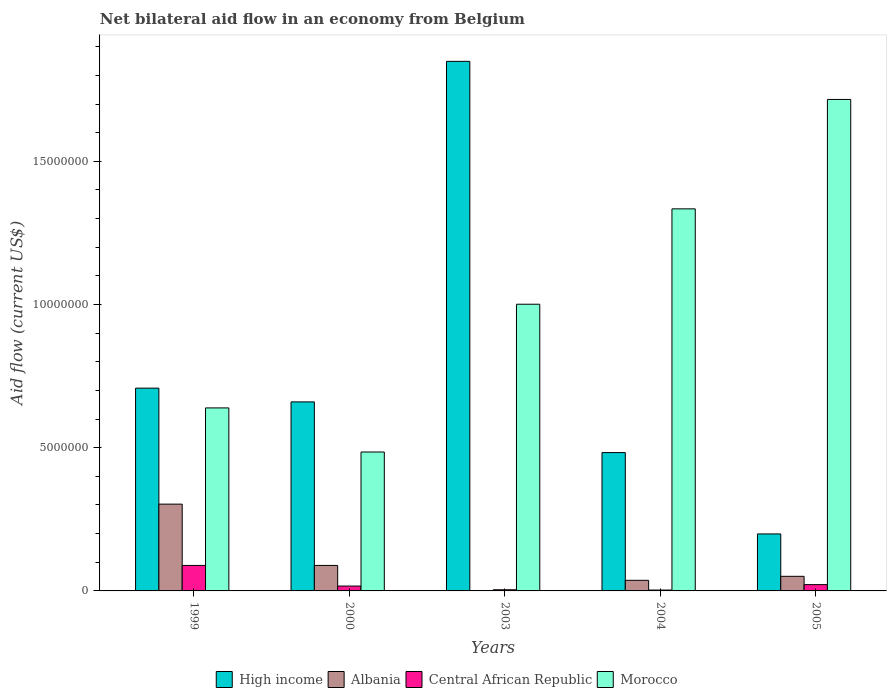How many different coloured bars are there?
Your answer should be very brief. 4. Are the number of bars per tick equal to the number of legend labels?
Keep it short and to the point. Yes. Are the number of bars on each tick of the X-axis equal?
Make the answer very short. Yes. How many bars are there on the 1st tick from the left?
Provide a succinct answer. 4. What is the label of the 3rd group of bars from the left?
Ensure brevity in your answer.  2003. In how many cases, is the number of bars for a given year not equal to the number of legend labels?
Your response must be concise. 0. What is the net bilateral aid flow in Albania in 2005?
Give a very brief answer. 5.10e+05. Across all years, what is the maximum net bilateral aid flow in Central African Republic?
Keep it short and to the point. 8.90e+05. Across all years, what is the minimum net bilateral aid flow in Morocco?
Provide a short and direct response. 4.85e+06. In which year was the net bilateral aid flow in Albania minimum?
Your response must be concise. 2003. What is the total net bilateral aid flow in Albania in the graph?
Provide a short and direct response. 4.81e+06. What is the difference between the net bilateral aid flow in Albania in 2003 and that in 2005?
Provide a short and direct response. -5.00e+05. What is the difference between the net bilateral aid flow in Morocco in 2000 and the net bilateral aid flow in High income in 2003?
Make the answer very short. -1.36e+07. What is the average net bilateral aid flow in Albania per year?
Keep it short and to the point. 9.62e+05. What is the ratio of the net bilateral aid flow in High income in 2000 to that in 2003?
Offer a terse response. 0.36. Is the difference between the net bilateral aid flow in Central African Republic in 2004 and 2005 greater than the difference between the net bilateral aid flow in Albania in 2004 and 2005?
Make the answer very short. No. What is the difference between the highest and the second highest net bilateral aid flow in Central African Republic?
Ensure brevity in your answer.  6.70e+05. What is the difference between the highest and the lowest net bilateral aid flow in Central African Republic?
Keep it short and to the point. 8.60e+05. What does the 1st bar from the left in 1999 represents?
Offer a terse response. High income. Are all the bars in the graph horizontal?
Provide a succinct answer. No. How many years are there in the graph?
Offer a very short reply. 5. What is the difference between two consecutive major ticks on the Y-axis?
Keep it short and to the point. 5.00e+06. Does the graph contain grids?
Your answer should be compact. No. Where does the legend appear in the graph?
Offer a very short reply. Bottom center. What is the title of the graph?
Give a very brief answer. Net bilateral aid flow in an economy from Belgium. What is the label or title of the Y-axis?
Give a very brief answer. Aid flow (current US$). What is the Aid flow (current US$) in High income in 1999?
Ensure brevity in your answer.  7.08e+06. What is the Aid flow (current US$) in Albania in 1999?
Your response must be concise. 3.03e+06. What is the Aid flow (current US$) of Central African Republic in 1999?
Provide a succinct answer. 8.90e+05. What is the Aid flow (current US$) of Morocco in 1999?
Offer a very short reply. 6.39e+06. What is the Aid flow (current US$) in High income in 2000?
Ensure brevity in your answer.  6.60e+06. What is the Aid flow (current US$) of Albania in 2000?
Your answer should be compact. 8.90e+05. What is the Aid flow (current US$) of Central African Republic in 2000?
Offer a very short reply. 1.70e+05. What is the Aid flow (current US$) of Morocco in 2000?
Offer a terse response. 4.85e+06. What is the Aid flow (current US$) of High income in 2003?
Provide a succinct answer. 1.85e+07. What is the Aid flow (current US$) of Central African Republic in 2003?
Make the answer very short. 4.00e+04. What is the Aid flow (current US$) of Morocco in 2003?
Your answer should be very brief. 1.00e+07. What is the Aid flow (current US$) of High income in 2004?
Provide a succinct answer. 4.83e+06. What is the Aid flow (current US$) in Albania in 2004?
Keep it short and to the point. 3.70e+05. What is the Aid flow (current US$) of Morocco in 2004?
Keep it short and to the point. 1.33e+07. What is the Aid flow (current US$) of High income in 2005?
Ensure brevity in your answer.  1.99e+06. What is the Aid flow (current US$) of Albania in 2005?
Your response must be concise. 5.10e+05. What is the Aid flow (current US$) in Morocco in 2005?
Provide a short and direct response. 1.72e+07. Across all years, what is the maximum Aid flow (current US$) of High income?
Give a very brief answer. 1.85e+07. Across all years, what is the maximum Aid flow (current US$) in Albania?
Provide a short and direct response. 3.03e+06. Across all years, what is the maximum Aid flow (current US$) of Central African Republic?
Offer a very short reply. 8.90e+05. Across all years, what is the maximum Aid flow (current US$) of Morocco?
Offer a terse response. 1.72e+07. Across all years, what is the minimum Aid flow (current US$) of High income?
Ensure brevity in your answer.  1.99e+06. Across all years, what is the minimum Aid flow (current US$) in Morocco?
Ensure brevity in your answer.  4.85e+06. What is the total Aid flow (current US$) in High income in the graph?
Give a very brief answer. 3.90e+07. What is the total Aid flow (current US$) in Albania in the graph?
Keep it short and to the point. 4.81e+06. What is the total Aid flow (current US$) in Central African Republic in the graph?
Provide a short and direct response. 1.35e+06. What is the total Aid flow (current US$) of Morocco in the graph?
Offer a terse response. 5.18e+07. What is the difference between the Aid flow (current US$) in High income in 1999 and that in 2000?
Your answer should be compact. 4.80e+05. What is the difference between the Aid flow (current US$) in Albania in 1999 and that in 2000?
Make the answer very short. 2.14e+06. What is the difference between the Aid flow (current US$) of Central African Republic in 1999 and that in 2000?
Make the answer very short. 7.20e+05. What is the difference between the Aid flow (current US$) of Morocco in 1999 and that in 2000?
Ensure brevity in your answer.  1.54e+06. What is the difference between the Aid flow (current US$) in High income in 1999 and that in 2003?
Your answer should be compact. -1.14e+07. What is the difference between the Aid flow (current US$) in Albania in 1999 and that in 2003?
Provide a short and direct response. 3.02e+06. What is the difference between the Aid flow (current US$) in Central African Republic in 1999 and that in 2003?
Your answer should be compact. 8.50e+05. What is the difference between the Aid flow (current US$) in Morocco in 1999 and that in 2003?
Provide a succinct answer. -3.62e+06. What is the difference between the Aid flow (current US$) of High income in 1999 and that in 2004?
Offer a very short reply. 2.25e+06. What is the difference between the Aid flow (current US$) in Albania in 1999 and that in 2004?
Keep it short and to the point. 2.66e+06. What is the difference between the Aid flow (current US$) of Central African Republic in 1999 and that in 2004?
Your answer should be very brief. 8.60e+05. What is the difference between the Aid flow (current US$) in Morocco in 1999 and that in 2004?
Offer a terse response. -6.95e+06. What is the difference between the Aid flow (current US$) in High income in 1999 and that in 2005?
Your response must be concise. 5.09e+06. What is the difference between the Aid flow (current US$) of Albania in 1999 and that in 2005?
Provide a succinct answer. 2.52e+06. What is the difference between the Aid flow (current US$) in Central African Republic in 1999 and that in 2005?
Your answer should be very brief. 6.70e+05. What is the difference between the Aid flow (current US$) of Morocco in 1999 and that in 2005?
Your answer should be very brief. -1.08e+07. What is the difference between the Aid flow (current US$) in High income in 2000 and that in 2003?
Provide a short and direct response. -1.19e+07. What is the difference between the Aid flow (current US$) of Albania in 2000 and that in 2003?
Provide a short and direct response. 8.80e+05. What is the difference between the Aid flow (current US$) in Central African Republic in 2000 and that in 2003?
Give a very brief answer. 1.30e+05. What is the difference between the Aid flow (current US$) of Morocco in 2000 and that in 2003?
Give a very brief answer. -5.16e+06. What is the difference between the Aid flow (current US$) of High income in 2000 and that in 2004?
Provide a short and direct response. 1.77e+06. What is the difference between the Aid flow (current US$) in Albania in 2000 and that in 2004?
Provide a short and direct response. 5.20e+05. What is the difference between the Aid flow (current US$) of Central African Republic in 2000 and that in 2004?
Your answer should be compact. 1.40e+05. What is the difference between the Aid flow (current US$) of Morocco in 2000 and that in 2004?
Offer a very short reply. -8.49e+06. What is the difference between the Aid flow (current US$) in High income in 2000 and that in 2005?
Your answer should be very brief. 4.61e+06. What is the difference between the Aid flow (current US$) of Albania in 2000 and that in 2005?
Your answer should be compact. 3.80e+05. What is the difference between the Aid flow (current US$) in Morocco in 2000 and that in 2005?
Your response must be concise. -1.23e+07. What is the difference between the Aid flow (current US$) in High income in 2003 and that in 2004?
Provide a short and direct response. 1.37e+07. What is the difference between the Aid flow (current US$) in Albania in 2003 and that in 2004?
Ensure brevity in your answer.  -3.60e+05. What is the difference between the Aid flow (current US$) in Central African Republic in 2003 and that in 2004?
Provide a succinct answer. 10000. What is the difference between the Aid flow (current US$) in Morocco in 2003 and that in 2004?
Provide a short and direct response. -3.33e+06. What is the difference between the Aid flow (current US$) in High income in 2003 and that in 2005?
Your answer should be very brief. 1.65e+07. What is the difference between the Aid flow (current US$) of Albania in 2003 and that in 2005?
Your answer should be compact. -5.00e+05. What is the difference between the Aid flow (current US$) in Central African Republic in 2003 and that in 2005?
Your response must be concise. -1.80e+05. What is the difference between the Aid flow (current US$) of Morocco in 2003 and that in 2005?
Keep it short and to the point. -7.15e+06. What is the difference between the Aid flow (current US$) in High income in 2004 and that in 2005?
Give a very brief answer. 2.84e+06. What is the difference between the Aid flow (current US$) of Albania in 2004 and that in 2005?
Give a very brief answer. -1.40e+05. What is the difference between the Aid flow (current US$) of Morocco in 2004 and that in 2005?
Keep it short and to the point. -3.82e+06. What is the difference between the Aid flow (current US$) in High income in 1999 and the Aid flow (current US$) in Albania in 2000?
Your response must be concise. 6.19e+06. What is the difference between the Aid flow (current US$) in High income in 1999 and the Aid flow (current US$) in Central African Republic in 2000?
Offer a very short reply. 6.91e+06. What is the difference between the Aid flow (current US$) of High income in 1999 and the Aid flow (current US$) of Morocco in 2000?
Your answer should be very brief. 2.23e+06. What is the difference between the Aid flow (current US$) of Albania in 1999 and the Aid flow (current US$) of Central African Republic in 2000?
Make the answer very short. 2.86e+06. What is the difference between the Aid flow (current US$) in Albania in 1999 and the Aid flow (current US$) in Morocco in 2000?
Your answer should be compact. -1.82e+06. What is the difference between the Aid flow (current US$) of Central African Republic in 1999 and the Aid flow (current US$) of Morocco in 2000?
Ensure brevity in your answer.  -3.96e+06. What is the difference between the Aid flow (current US$) in High income in 1999 and the Aid flow (current US$) in Albania in 2003?
Keep it short and to the point. 7.07e+06. What is the difference between the Aid flow (current US$) of High income in 1999 and the Aid flow (current US$) of Central African Republic in 2003?
Offer a very short reply. 7.04e+06. What is the difference between the Aid flow (current US$) in High income in 1999 and the Aid flow (current US$) in Morocco in 2003?
Your response must be concise. -2.93e+06. What is the difference between the Aid flow (current US$) of Albania in 1999 and the Aid flow (current US$) of Central African Republic in 2003?
Your answer should be compact. 2.99e+06. What is the difference between the Aid flow (current US$) of Albania in 1999 and the Aid flow (current US$) of Morocco in 2003?
Provide a succinct answer. -6.98e+06. What is the difference between the Aid flow (current US$) of Central African Republic in 1999 and the Aid flow (current US$) of Morocco in 2003?
Your response must be concise. -9.12e+06. What is the difference between the Aid flow (current US$) of High income in 1999 and the Aid flow (current US$) of Albania in 2004?
Ensure brevity in your answer.  6.71e+06. What is the difference between the Aid flow (current US$) of High income in 1999 and the Aid flow (current US$) of Central African Republic in 2004?
Provide a succinct answer. 7.05e+06. What is the difference between the Aid flow (current US$) in High income in 1999 and the Aid flow (current US$) in Morocco in 2004?
Your response must be concise. -6.26e+06. What is the difference between the Aid flow (current US$) of Albania in 1999 and the Aid flow (current US$) of Morocco in 2004?
Keep it short and to the point. -1.03e+07. What is the difference between the Aid flow (current US$) in Central African Republic in 1999 and the Aid flow (current US$) in Morocco in 2004?
Ensure brevity in your answer.  -1.24e+07. What is the difference between the Aid flow (current US$) of High income in 1999 and the Aid flow (current US$) of Albania in 2005?
Provide a short and direct response. 6.57e+06. What is the difference between the Aid flow (current US$) of High income in 1999 and the Aid flow (current US$) of Central African Republic in 2005?
Keep it short and to the point. 6.86e+06. What is the difference between the Aid flow (current US$) in High income in 1999 and the Aid flow (current US$) in Morocco in 2005?
Your response must be concise. -1.01e+07. What is the difference between the Aid flow (current US$) in Albania in 1999 and the Aid flow (current US$) in Central African Republic in 2005?
Ensure brevity in your answer.  2.81e+06. What is the difference between the Aid flow (current US$) in Albania in 1999 and the Aid flow (current US$) in Morocco in 2005?
Your response must be concise. -1.41e+07. What is the difference between the Aid flow (current US$) in Central African Republic in 1999 and the Aid flow (current US$) in Morocco in 2005?
Keep it short and to the point. -1.63e+07. What is the difference between the Aid flow (current US$) in High income in 2000 and the Aid flow (current US$) in Albania in 2003?
Your response must be concise. 6.59e+06. What is the difference between the Aid flow (current US$) of High income in 2000 and the Aid flow (current US$) of Central African Republic in 2003?
Offer a terse response. 6.56e+06. What is the difference between the Aid flow (current US$) in High income in 2000 and the Aid flow (current US$) in Morocco in 2003?
Provide a succinct answer. -3.41e+06. What is the difference between the Aid flow (current US$) in Albania in 2000 and the Aid flow (current US$) in Central African Republic in 2003?
Your answer should be very brief. 8.50e+05. What is the difference between the Aid flow (current US$) of Albania in 2000 and the Aid flow (current US$) of Morocco in 2003?
Ensure brevity in your answer.  -9.12e+06. What is the difference between the Aid flow (current US$) of Central African Republic in 2000 and the Aid flow (current US$) of Morocco in 2003?
Offer a terse response. -9.84e+06. What is the difference between the Aid flow (current US$) of High income in 2000 and the Aid flow (current US$) of Albania in 2004?
Offer a very short reply. 6.23e+06. What is the difference between the Aid flow (current US$) in High income in 2000 and the Aid flow (current US$) in Central African Republic in 2004?
Offer a terse response. 6.57e+06. What is the difference between the Aid flow (current US$) in High income in 2000 and the Aid flow (current US$) in Morocco in 2004?
Your response must be concise. -6.74e+06. What is the difference between the Aid flow (current US$) in Albania in 2000 and the Aid flow (current US$) in Central African Republic in 2004?
Give a very brief answer. 8.60e+05. What is the difference between the Aid flow (current US$) of Albania in 2000 and the Aid flow (current US$) of Morocco in 2004?
Offer a terse response. -1.24e+07. What is the difference between the Aid flow (current US$) in Central African Republic in 2000 and the Aid flow (current US$) in Morocco in 2004?
Offer a very short reply. -1.32e+07. What is the difference between the Aid flow (current US$) of High income in 2000 and the Aid flow (current US$) of Albania in 2005?
Provide a short and direct response. 6.09e+06. What is the difference between the Aid flow (current US$) of High income in 2000 and the Aid flow (current US$) of Central African Republic in 2005?
Keep it short and to the point. 6.38e+06. What is the difference between the Aid flow (current US$) of High income in 2000 and the Aid flow (current US$) of Morocco in 2005?
Your response must be concise. -1.06e+07. What is the difference between the Aid flow (current US$) of Albania in 2000 and the Aid flow (current US$) of Central African Republic in 2005?
Ensure brevity in your answer.  6.70e+05. What is the difference between the Aid flow (current US$) in Albania in 2000 and the Aid flow (current US$) in Morocco in 2005?
Your answer should be compact. -1.63e+07. What is the difference between the Aid flow (current US$) of Central African Republic in 2000 and the Aid flow (current US$) of Morocco in 2005?
Offer a very short reply. -1.70e+07. What is the difference between the Aid flow (current US$) in High income in 2003 and the Aid flow (current US$) in Albania in 2004?
Provide a succinct answer. 1.81e+07. What is the difference between the Aid flow (current US$) in High income in 2003 and the Aid flow (current US$) in Central African Republic in 2004?
Ensure brevity in your answer.  1.85e+07. What is the difference between the Aid flow (current US$) in High income in 2003 and the Aid flow (current US$) in Morocco in 2004?
Offer a terse response. 5.15e+06. What is the difference between the Aid flow (current US$) in Albania in 2003 and the Aid flow (current US$) in Morocco in 2004?
Provide a short and direct response. -1.33e+07. What is the difference between the Aid flow (current US$) in Central African Republic in 2003 and the Aid flow (current US$) in Morocco in 2004?
Keep it short and to the point. -1.33e+07. What is the difference between the Aid flow (current US$) in High income in 2003 and the Aid flow (current US$) in Albania in 2005?
Ensure brevity in your answer.  1.80e+07. What is the difference between the Aid flow (current US$) of High income in 2003 and the Aid flow (current US$) of Central African Republic in 2005?
Offer a very short reply. 1.83e+07. What is the difference between the Aid flow (current US$) of High income in 2003 and the Aid flow (current US$) of Morocco in 2005?
Your answer should be compact. 1.33e+06. What is the difference between the Aid flow (current US$) of Albania in 2003 and the Aid flow (current US$) of Central African Republic in 2005?
Offer a very short reply. -2.10e+05. What is the difference between the Aid flow (current US$) in Albania in 2003 and the Aid flow (current US$) in Morocco in 2005?
Make the answer very short. -1.72e+07. What is the difference between the Aid flow (current US$) in Central African Republic in 2003 and the Aid flow (current US$) in Morocco in 2005?
Give a very brief answer. -1.71e+07. What is the difference between the Aid flow (current US$) of High income in 2004 and the Aid flow (current US$) of Albania in 2005?
Provide a short and direct response. 4.32e+06. What is the difference between the Aid flow (current US$) in High income in 2004 and the Aid flow (current US$) in Central African Republic in 2005?
Your answer should be compact. 4.61e+06. What is the difference between the Aid flow (current US$) in High income in 2004 and the Aid flow (current US$) in Morocco in 2005?
Give a very brief answer. -1.23e+07. What is the difference between the Aid flow (current US$) of Albania in 2004 and the Aid flow (current US$) of Central African Republic in 2005?
Offer a very short reply. 1.50e+05. What is the difference between the Aid flow (current US$) in Albania in 2004 and the Aid flow (current US$) in Morocco in 2005?
Offer a terse response. -1.68e+07. What is the difference between the Aid flow (current US$) of Central African Republic in 2004 and the Aid flow (current US$) of Morocco in 2005?
Your answer should be compact. -1.71e+07. What is the average Aid flow (current US$) in High income per year?
Make the answer very short. 7.80e+06. What is the average Aid flow (current US$) in Albania per year?
Keep it short and to the point. 9.62e+05. What is the average Aid flow (current US$) of Morocco per year?
Ensure brevity in your answer.  1.04e+07. In the year 1999, what is the difference between the Aid flow (current US$) in High income and Aid flow (current US$) in Albania?
Make the answer very short. 4.05e+06. In the year 1999, what is the difference between the Aid flow (current US$) of High income and Aid flow (current US$) of Central African Republic?
Make the answer very short. 6.19e+06. In the year 1999, what is the difference between the Aid flow (current US$) in High income and Aid flow (current US$) in Morocco?
Offer a very short reply. 6.90e+05. In the year 1999, what is the difference between the Aid flow (current US$) of Albania and Aid flow (current US$) of Central African Republic?
Ensure brevity in your answer.  2.14e+06. In the year 1999, what is the difference between the Aid flow (current US$) in Albania and Aid flow (current US$) in Morocco?
Your answer should be very brief. -3.36e+06. In the year 1999, what is the difference between the Aid flow (current US$) of Central African Republic and Aid flow (current US$) of Morocco?
Give a very brief answer. -5.50e+06. In the year 2000, what is the difference between the Aid flow (current US$) in High income and Aid flow (current US$) in Albania?
Provide a short and direct response. 5.71e+06. In the year 2000, what is the difference between the Aid flow (current US$) of High income and Aid flow (current US$) of Central African Republic?
Offer a very short reply. 6.43e+06. In the year 2000, what is the difference between the Aid flow (current US$) of High income and Aid flow (current US$) of Morocco?
Your answer should be compact. 1.75e+06. In the year 2000, what is the difference between the Aid flow (current US$) of Albania and Aid flow (current US$) of Central African Republic?
Your answer should be compact. 7.20e+05. In the year 2000, what is the difference between the Aid flow (current US$) in Albania and Aid flow (current US$) in Morocco?
Ensure brevity in your answer.  -3.96e+06. In the year 2000, what is the difference between the Aid flow (current US$) of Central African Republic and Aid flow (current US$) of Morocco?
Your response must be concise. -4.68e+06. In the year 2003, what is the difference between the Aid flow (current US$) in High income and Aid flow (current US$) in Albania?
Your answer should be compact. 1.85e+07. In the year 2003, what is the difference between the Aid flow (current US$) of High income and Aid flow (current US$) of Central African Republic?
Your answer should be very brief. 1.84e+07. In the year 2003, what is the difference between the Aid flow (current US$) in High income and Aid flow (current US$) in Morocco?
Provide a short and direct response. 8.48e+06. In the year 2003, what is the difference between the Aid flow (current US$) in Albania and Aid flow (current US$) in Morocco?
Your answer should be compact. -1.00e+07. In the year 2003, what is the difference between the Aid flow (current US$) of Central African Republic and Aid flow (current US$) of Morocco?
Offer a terse response. -9.97e+06. In the year 2004, what is the difference between the Aid flow (current US$) in High income and Aid flow (current US$) in Albania?
Offer a terse response. 4.46e+06. In the year 2004, what is the difference between the Aid flow (current US$) in High income and Aid flow (current US$) in Central African Republic?
Offer a terse response. 4.80e+06. In the year 2004, what is the difference between the Aid flow (current US$) of High income and Aid flow (current US$) of Morocco?
Your answer should be very brief. -8.51e+06. In the year 2004, what is the difference between the Aid flow (current US$) in Albania and Aid flow (current US$) in Central African Republic?
Keep it short and to the point. 3.40e+05. In the year 2004, what is the difference between the Aid flow (current US$) in Albania and Aid flow (current US$) in Morocco?
Offer a very short reply. -1.30e+07. In the year 2004, what is the difference between the Aid flow (current US$) in Central African Republic and Aid flow (current US$) in Morocco?
Give a very brief answer. -1.33e+07. In the year 2005, what is the difference between the Aid flow (current US$) of High income and Aid flow (current US$) of Albania?
Offer a terse response. 1.48e+06. In the year 2005, what is the difference between the Aid flow (current US$) of High income and Aid flow (current US$) of Central African Republic?
Offer a terse response. 1.77e+06. In the year 2005, what is the difference between the Aid flow (current US$) in High income and Aid flow (current US$) in Morocco?
Provide a succinct answer. -1.52e+07. In the year 2005, what is the difference between the Aid flow (current US$) in Albania and Aid flow (current US$) in Morocco?
Your response must be concise. -1.66e+07. In the year 2005, what is the difference between the Aid flow (current US$) of Central African Republic and Aid flow (current US$) of Morocco?
Your answer should be very brief. -1.69e+07. What is the ratio of the Aid flow (current US$) of High income in 1999 to that in 2000?
Keep it short and to the point. 1.07. What is the ratio of the Aid flow (current US$) of Albania in 1999 to that in 2000?
Keep it short and to the point. 3.4. What is the ratio of the Aid flow (current US$) of Central African Republic in 1999 to that in 2000?
Give a very brief answer. 5.24. What is the ratio of the Aid flow (current US$) of Morocco in 1999 to that in 2000?
Keep it short and to the point. 1.32. What is the ratio of the Aid flow (current US$) of High income in 1999 to that in 2003?
Your response must be concise. 0.38. What is the ratio of the Aid flow (current US$) in Albania in 1999 to that in 2003?
Keep it short and to the point. 303. What is the ratio of the Aid flow (current US$) in Central African Republic in 1999 to that in 2003?
Keep it short and to the point. 22.25. What is the ratio of the Aid flow (current US$) in Morocco in 1999 to that in 2003?
Ensure brevity in your answer.  0.64. What is the ratio of the Aid flow (current US$) in High income in 1999 to that in 2004?
Provide a short and direct response. 1.47. What is the ratio of the Aid flow (current US$) in Albania in 1999 to that in 2004?
Offer a very short reply. 8.19. What is the ratio of the Aid flow (current US$) in Central African Republic in 1999 to that in 2004?
Give a very brief answer. 29.67. What is the ratio of the Aid flow (current US$) of Morocco in 1999 to that in 2004?
Give a very brief answer. 0.48. What is the ratio of the Aid flow (current US$) in High income in 1999 to that in 2005?
Make the answer very short. 3.56. What is the ratio of the Aid flow (current US$) of Albania in 1999 to that in 2005?
Provide a short and direct response. 5.94. What is the ratio of the Aid flow (current US$) in Central African Republic in 1999 to that in 2005?
Your response must be concise. 4.05. What is the ratio of the Aid flow (current US$) of Morocco in 1999 to that in 2005?
Your answer should be compact. 0.37. What is the ratio of the Aid flow (current US$) of High income in 2000 to that in 2003?
Keep it short and to the point. 0.36. What is the ratio of the Aid flow (current US$) in Albania in 2000 to that in 2003?
Your answer should be compact. 89. What is the ratio of the Aid flow (current US$) of Central African Republic in 2000 to that in 2003?
Provide a short and direct response. 4.25. What is the ratio of the Aid flow (current US$) in Morocco in 2000 to that in 2003?
Your response must be concise. 0.48. What is the ratio of the Aid flow (current US$) of High income in 2000 to that in 2004?
Keep it short and to the point. 1.37. What is the ratio of the Aid flow (current US$) in Albania in 2000 to that in 2004?
Your answer should be compact. 2.41. What is the ratio of the Aid flow (current US$) in Central African Republic in 2000 to that in 2004?
Provide a short and direct response. 5.67. What is the ratio of the Aid flow (current US$) in Morocco in 2000 to that in 2004?
Offer a terse response. 0.36. What is the ratio of the Aid flow (current US$) in High income in 2000 to that in 2005?
Your answer should be very brief. 3.32. What is the ratio of the Aid flow (current US$) in Albania in 2000 to that in 2005?
Offer a very short reply. 1.75. What is the ratio of the Aid flow (current US$) in Central African Republic in 2000 to that in 2005?
Offer a terse response. 0.77. What is the ratio of the Aid flow (current US$) in Morocco in 2000 to that in 2005?
Your response must be concise. 0.28. What is the ratio of the Aid flow (current US$) in High income in 2003 to that in 2004?
Keep it short and to the point. 3.83. What is the ratio of the Aid flow (current US$) of Albania in 2003 to that in 2004?
Offer a very short reply. 0.03. What is the ratio of the Aid flow (current US$) of Central African Republic in 2003 to that in 2004?
Ensure brevity in your answer.  1.33. What is the ratio of the Aid flow (current US$) in Morocco in 2003 to that in 2004?
Offer a terse response. 0.75. What is the ratio of the Aid flow (current US$) in High income in 2003 to that in 2005?
Give a very brief answer. 9.29. What is the ratio of the Aid flow (current US$) in Albania in 2003 to that in 2005?
Make the answer very short. 0.02. What is the ratio of the Aid flow (current US$) of Central African Republic in 2003 to that in 2005?
Provide a short and direct response. 0.18. What is the ratio of the Aid flow (current US$) of Morocco in 2003 to that in 2005?
Make the answer very short. 0.58. What is the ratio of the Aid flow (current US$) in High income in 2004 to that in 2005?
Provide a short and direct response. 2.43. What is the ratio of the Aid flow (current US$) of Albania in 2004 to that in 2005?
Give a very brief answer. 0.73. What is the ratio of the Aid flow (current US$) in Central African Republic in 2004 to that in 2005?
Offer a very short reply. 0.14. What is the ratio of the Aid flow (current US$) in Morocco in 2004 to that in 2005?
Provide a succinct answer. 0.78. What is the difference between the highest and the second highest Aid flow (current US$) in High income?
Keep it short and to the point. 1.14e+07. What is the difference between the highest and the second highest Aid flow (current US$) of Albania?
Provide a short and direct response. 2.14e+06. What is the difference between the highest and the second highest Aid flow (current US$) of Central African Republic?
Provide a short and direct response. 6.70e+05. What is the difference between the highest and the second highest Aid flow (current US$) of Morocco?
Offer a terse response. 3.82e+06. What is the difference between the highest and the lowest Aid flow (current US$) of High income?
Keep it short and to the point. 1.65e+07. What is the difference between the highest and the lowest Aid flow (current US$) of Albania?
Your response must be concise. 3.02e+06. What is the difference between the highest and the lowest Aid flow (current US$) in Central African Republic?
Offer a terse response. 8.60e+05. What is the difference between the highest and the lowest Aid flow (current US$) of Morocco?
Provide a succinct answer. 1.23e+07. 